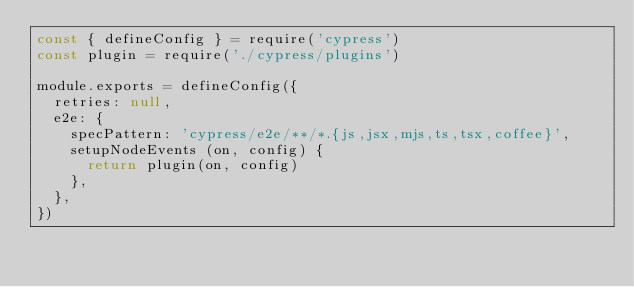<code> <loc_0><loc_0><loc_500><loc_500><_JavaScript_>const { defineConfig } = require('cypress')
const plugin = require('./cypress/plugins')

module.exports = defineConfig({
  retries: null,
  e2e: {
    specPattern: 'cypress/e2e/**/*.{js,jsx,mjs,ts,tsx,coffee}',
    setupNodeEvents (on, config) {
      return plugin(on, config)
    },
  },
})
</code> 